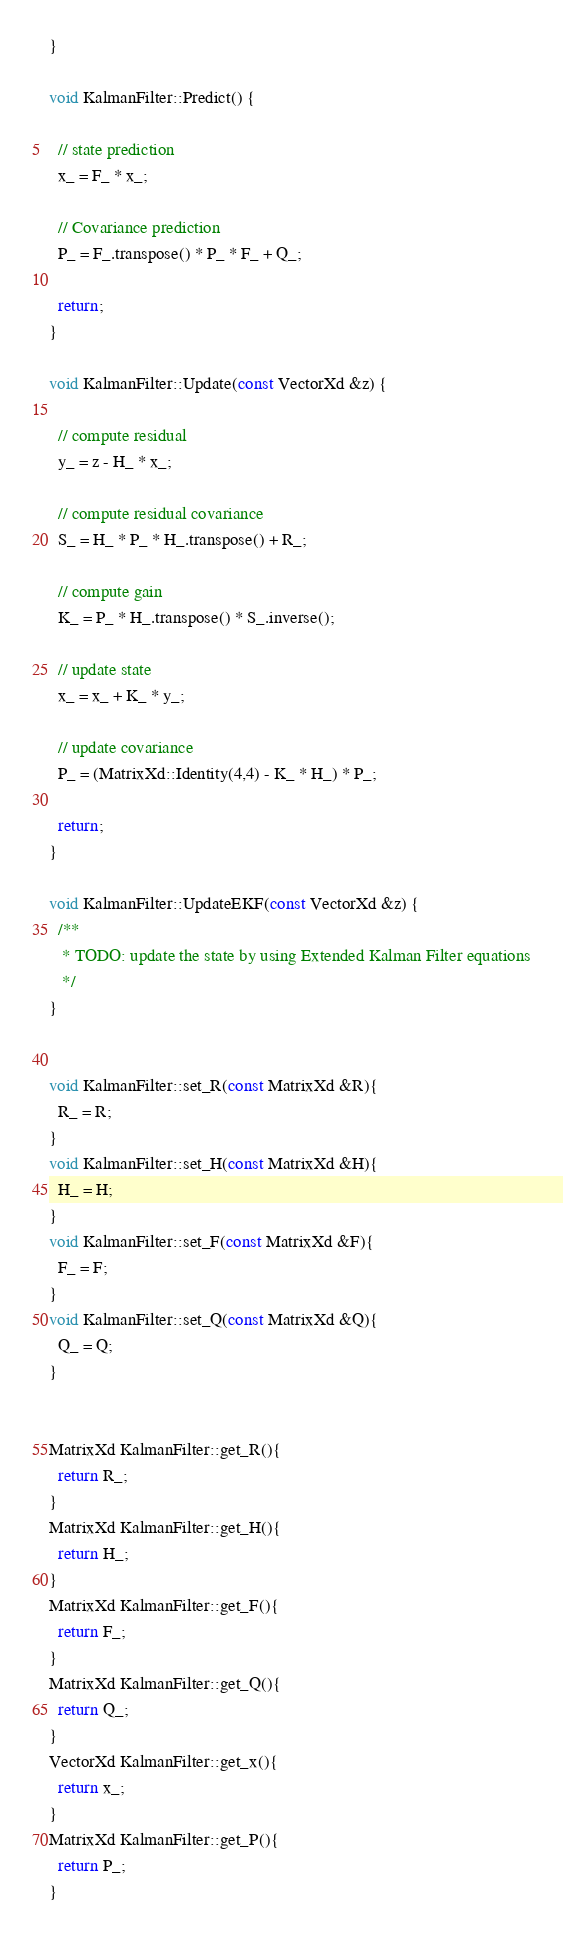<code> <loc_0><loc_0><loc_500><loc_500><_C++_>}

void KalmanFilter::Predict() {

  // state prediction
  x_ = F_ * x_;

  // Covariance prediction
  P_ = F_.transpose() * P_ * F_ + Q_;

  return;
}

void KalmanFilter::Update(const VectorXd &z) {

  // compute residual
  y_ = z - H_ * x_;

  // compute residual covariance
  S_ = H_ * P_ * H_.transpose() + R_;

  // compute gain
  K_ = P_ * H_.transpose() * S_.inverse();

  // update state
  x_ = x_ + K_ * y_;

  // update covariance
  P_ = (MatrixXd::Identity(4,4) - K_ * H_) * P_;

  return;
}

void KalmanFilter::UpdateEKF(const VectorXd &z) {
  /**
   * TODO: update the state by using Extended Kalman Filter equations
   */
}


void KalmanFilter::set_R(const MatrixXd &R){
  R_ = R;
}
void KalmanFilter::set_H(const MatrixXd &H){
  H_ = H;
}
void KalmanFilter::set_F(const MatrixXd &F){
  F_ = F;
}
void KalmanFilter::set_Q(const MatrixXd &Q){
  Q_ = Q;
}


MatrixXd KalmanFilter::get_R(){
  return R_;
}
MatrixXd KalmanFilter::get_H(){
  return H_;
}
MatrixXd KalmanFilter::get_F(){
  return F_;
}
MatrixXd KalmanFilter::get_Q(){
  return Q_;
}
VectorXd KalmanFilter::get_x(){
  return x_;
}
MatrixXd KalmanFilter::get_P(){
  return P_;
}


</code> 